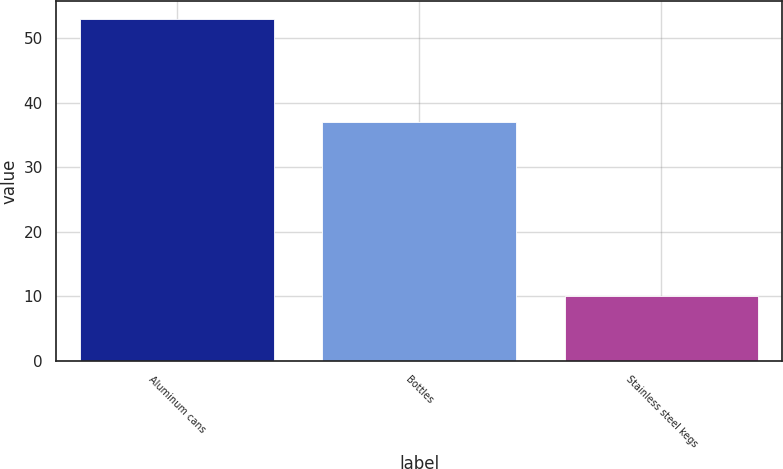Convert chart. <chart><loc_0><loc_0><loc_500><loc_500><bar_chart><fcel>Aluminum cans<fcel>Bottles<fcel>Stainless steel kegs<nl><fcel>53<fcel>37<fcel>10<nl></chart> 